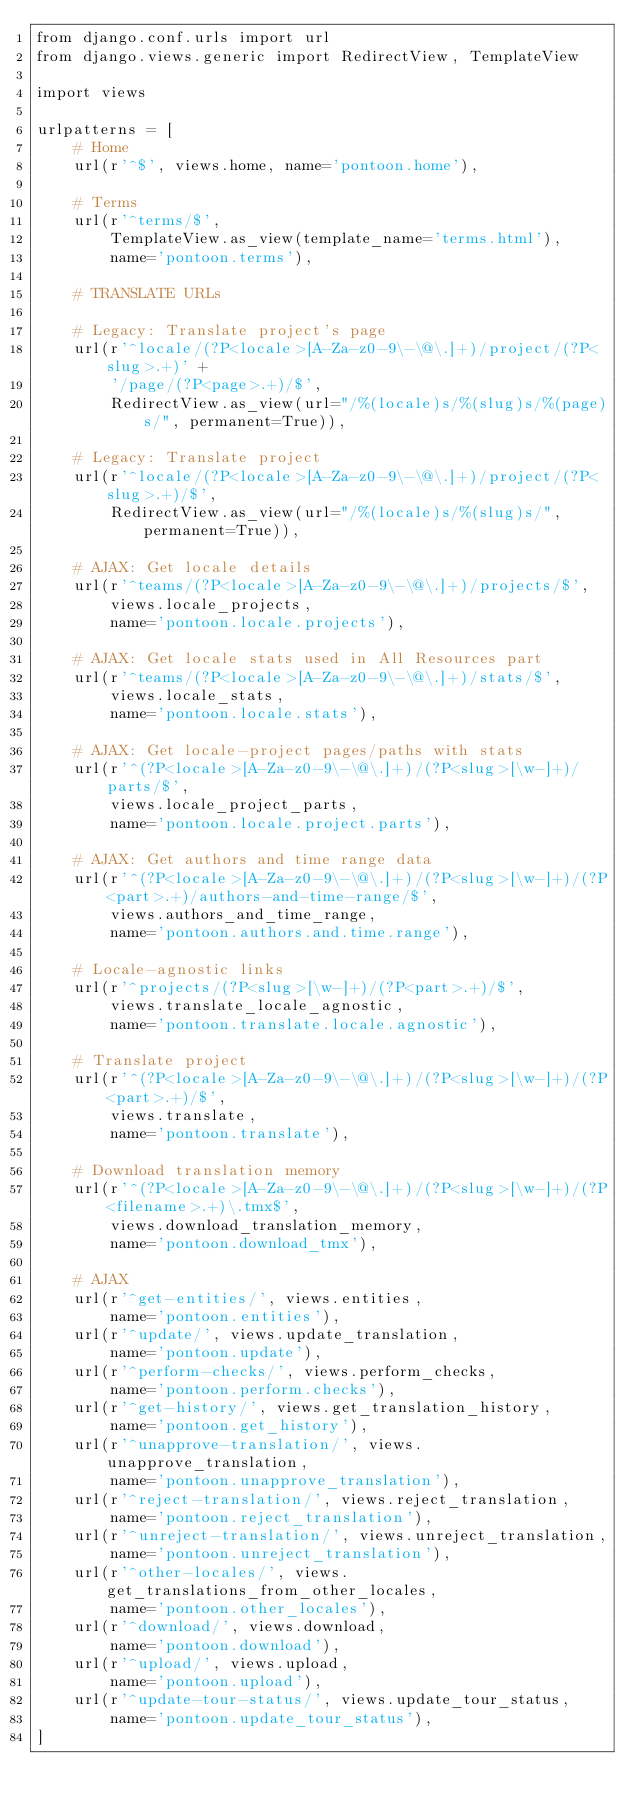Convert code to text. <code><loc_0><loc_0><loc_500><loc_500><_Python_>from django.conf.urls import url
from django.views.generic import RedirectView, TemplateView

import views

urlpatterns = [
    # Home
    url(r'^$', views.home, name='pontoon.home'),

    # Terms
    url(r'^terms/$',
        TemplateView.as_view(template_name='terms.html'),
        name='pontoon.terms'),

    # TRANSLATE URLs

    # Legacy: Translate project's page
    url(r'^locale/(?P<locale>[A-Za-z0-9\-\@\.]+)/project/(?P<slug>.+)' +
        '/page/(?P<page>.+)/$',
        RedirectView.as_view(url="/%(locale)s/%(slug)s/%(page)s/", permanent=True)),

    # Legacy: Translate project
    url(r'^locale/(?P<locale>[A-Za-z0-9\-\@\.]+)/project/(?P<slug>.+)/$',
        RedirectView.as_view(url="/%(locale)s/%(slug)s/", permanent=True)),

    # AJAX: Get locale details
    url(r'^teams/(?P<locale>[A-Za-z0-9\-\@\.]+)/projects/$',
        views.locale_projects,
        name='pontoon.locale.projects'),

    # AJAX: Get locale stats used in All Resources part
    url(r'^teams/(?P<locale>[A-Za-z0-9\-\@\.]+)/stats/$',
        views.locale_stats,
        name='pontoon.locale.stats'),

    # AJAX: Get locale-project pages/paths with stats
    url(r'^(?P<locale>[A-Za-z0-9\-\@\.]+)/(?P<slug>[\w-]+)/parts/$',
        views.locale_project_parts,
        name='pontoon.locale.project.parts'),

    # AJAX: Get authors and time range data
    url(r'^(?P<locale>[A-Za-z0-9\-\@\.]+)/(?P<slug>[\w-]+)/(?P<part>.+)/authors-and-time-range/$',
        views.authors_and_time_range,
        name='pontoon.authors.and.time.range'),

    # Locale-agnostic links
    url(r'^projects/(?P<slug>[\w-]+)/(?P<part>.+)/$',
        views.translate_locale_agnostic,
        name='pontoon.translate.locale.agnostic'),

    # Translate project
    url(r'^(?P<locale>[A-Za-z0-9\-\@\.]+)/(?P<slug>[\w-]+)/(?P<part>.+)/$',
        views.translate,
        name='pontoon.translate'),

    # Download translation memory
    url(r'^(?P<locale>[A-Za-z0-9\-\@\.]+)/(?P<slug>[\w-]+)/(?P<filename>.+)\.tmx$',
        views.download_translation_memory,
        name='pontoon.download_tmx'),

    # AJAX
    url(r'^get-entities/', views.entities,
        name='pontoon.entities'),
    url(r'^update/', views.update_translation,
        name='pontoon.update'),
    url(r'^perform-checks/', views.perform_checks,
        name='pontoon.perform.checks'),
    url(r'^get-history/', views.get_translation_history,
        name='pontoon.get_history'),
    url(r'^unapprove-translation/', views.unapprove_translation,
        name='pontoon.unapprove_translation'),
    url(r'^reject-translation/', views.reject_translation,
        name='pontoon.reject_translation'),
    url(r'^unreject-translation/', views.unreject_translation,
        name='pontoon.unreject_translation'),
    url(r'^other-locales/', views.get_translations_from_other_locales,
        name='pontoon.other_locales'),
    url(r'^download/', views.download,
        name='pontoon.download'),
    url(r'^upload/', views.upload,
        name='pontoon.upload'),
    url(r'^update-tour-status/', views.update_tour_status,
        name='pontoon.update_tour_status'),
]
</code> 